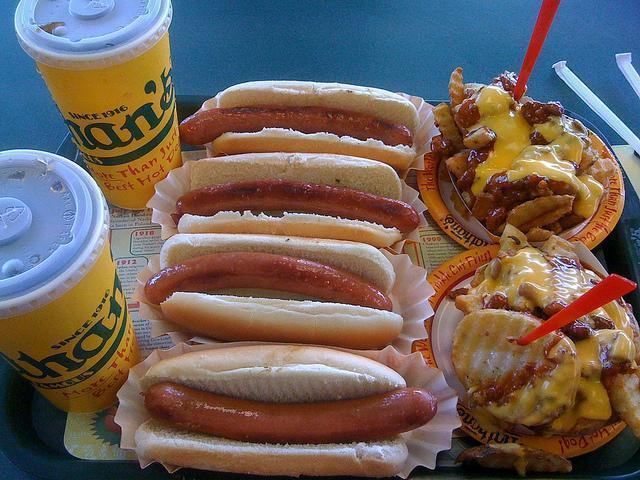What annual event is the company famous for?
Make your selection and explain in format: 'Answer: answer
Rationale: rationale.'
Options: Butchering contest, barbecue contest, eating contest, cooking contest. Answer: eating contest.
Rationale: Nathan's has a hot dog eating contest. 